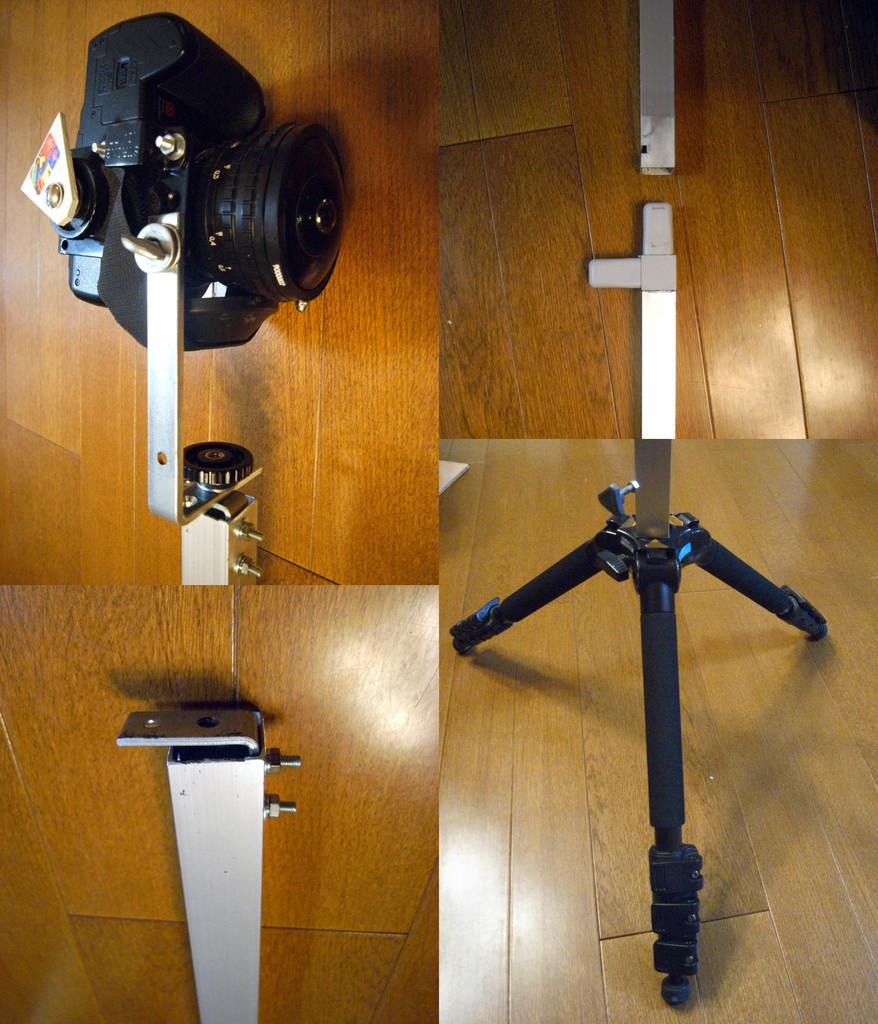What type of image is being described? The image is a collage. What can be seen in the collage? There is a stand and a camera on a platform in the image. Can you describe the stand in the collage? Unfortunately, the details of the stand are not provided in the facts, so we cannot describe it further. What unit of measurement is used to describe the hope in the image? There is no mention of hope in the image, so it cannot be measured or described. 